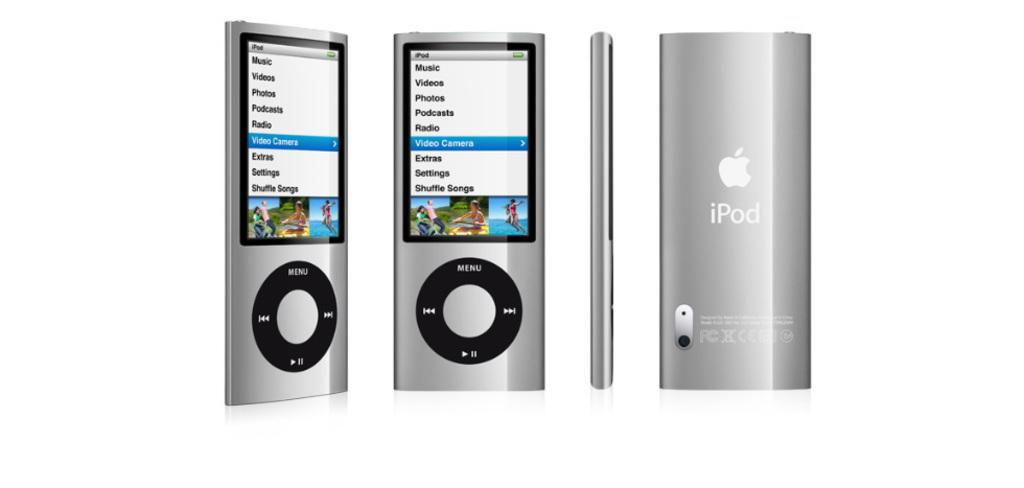<image>
Relay a brief, clear account of the picture shown. A silver iPod shows a menu with "music" as the top option. 